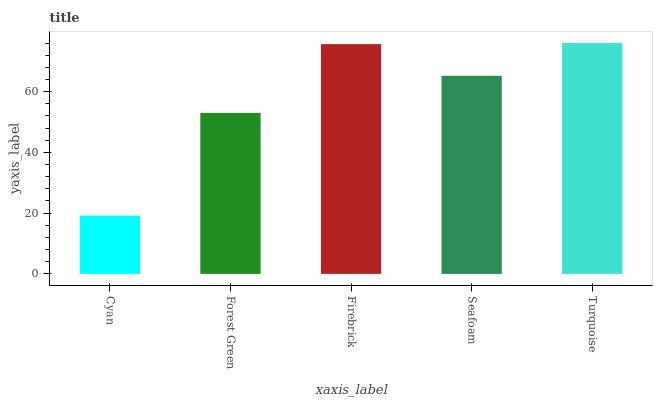Is Forest Green the minimum?
Answer yes or no. No. Is Forest Green the maximum?
Answer yes or no. No. Is Forest Green greater than Cyan?
Answer yes or no. Yes. Is Cyan less than Forest Green?
Answer yes or no. Yes. Is Cyan greater than Forest Green?
Answer yes or no. No. Is Forest Green less than Cyan?
Answer yes or no. No. Is Seafoam the high median?
Answer yes or no. Yes. Is Seafoam the low median?
Answer yes or no. Yes. Is Turquoise the high median?
Answer yes or no. No. Is Firebrick the low median?
Answer yes or no. No. 